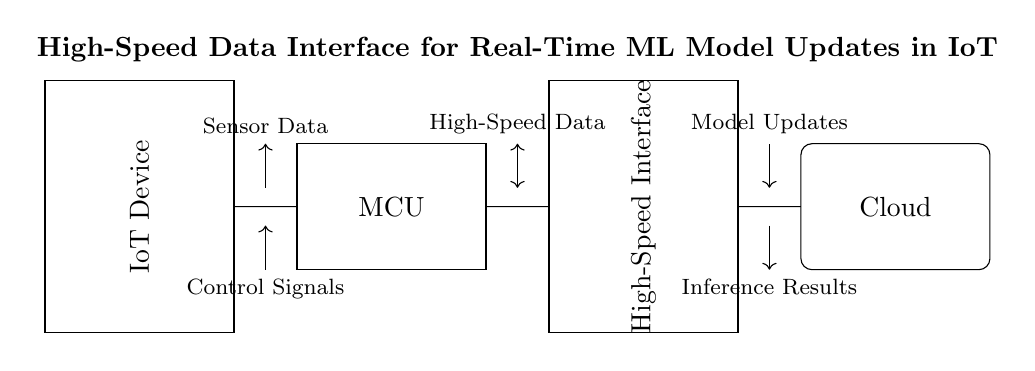What is the primary component representing the IoT device? The primary component representing the IoT device is the rectangular box labeled "IoT Device" in the diagram. This box signifies the core of the circuit where sensor data is processed.
Answer: IoT Device What type of connection is between the MCU and the high-speed interface? The connection between the MCU and the high-speed interface is depicted as a short wire, indicating a simple electrical connection designed for fast data transfer directly between these components.
Answer: High-Speed Data What type of data is transmitted from the IoT device to the cloud? The data being transmitted from the IoT device to the cloud is indicated as "Model Updates," which refers to the updates sent to improve or modify the machine learning model.
Answer: Model Updates Which signals are sent from the IoT device to the MCU? The signals sent from the IoT device to the MCU, according to the diagram, are labeled as "Control Signals," which are essential for managing how the MCU interacts with the IoT device's functions.
Answer: Control Signals What role does the cloud play in this circuit diagram? The cloud functions as a destination for receiving model updates from the IoT device, as indicated by the "Cloud" box, which is where the processed information is sent for further analysis and storage.
Answer: Cloud Why might a high-speed interface be necessary in this circuit? A high-speed interface is necessary in this circuit to ensure rapid transmission of data between the IoT device and the cloud, enabling real-time updates and inferences critical for machine learning applications.
Answer: High-Speed Interface 